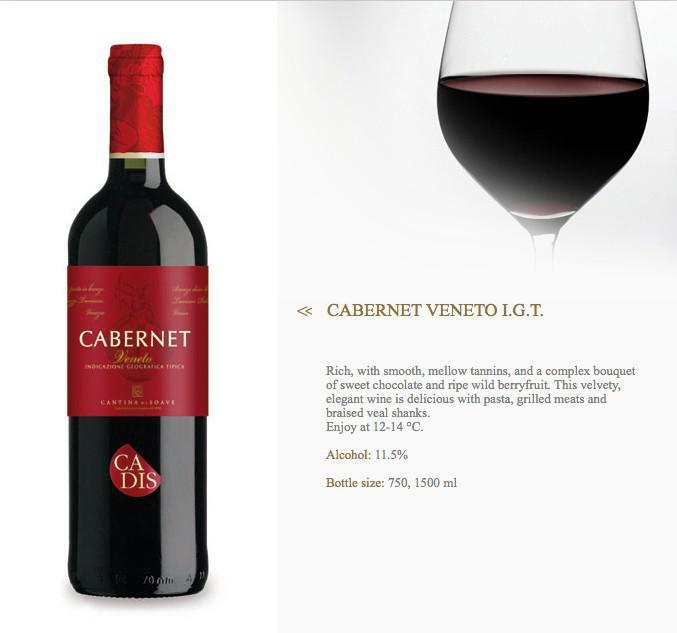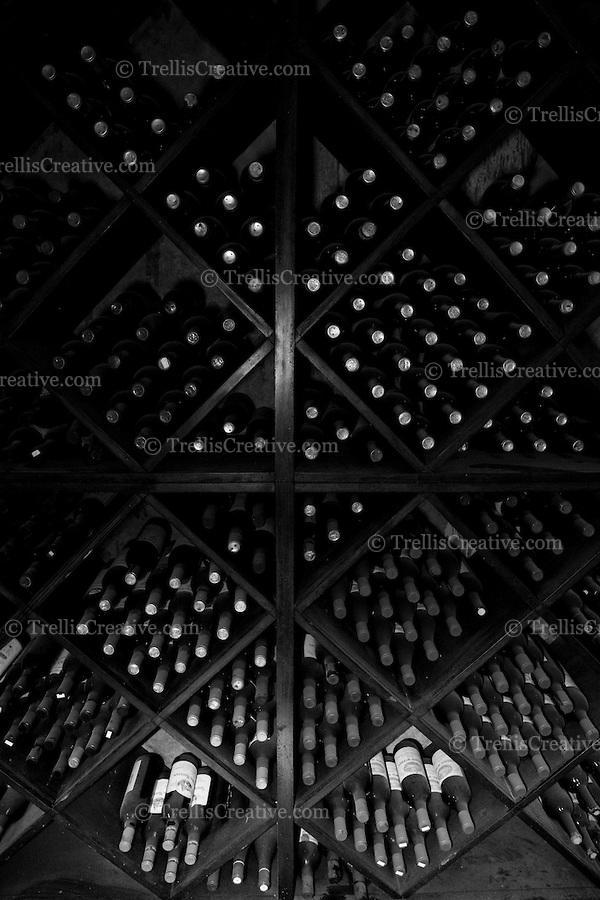The first image is the image on the left, the second image is the image on the right. Evaluate the accuracy of this statement regarding the images: "A single bottle and glass of wine are in one of the images.". Is it true? Answer yes or no. Yes. The first image is the image on the left, the second image is the image on the right. For the images shown, is this caption "There is a glass of red wine next to a bottle of wine in one of the images" true? Answer yes or no. Yes. 